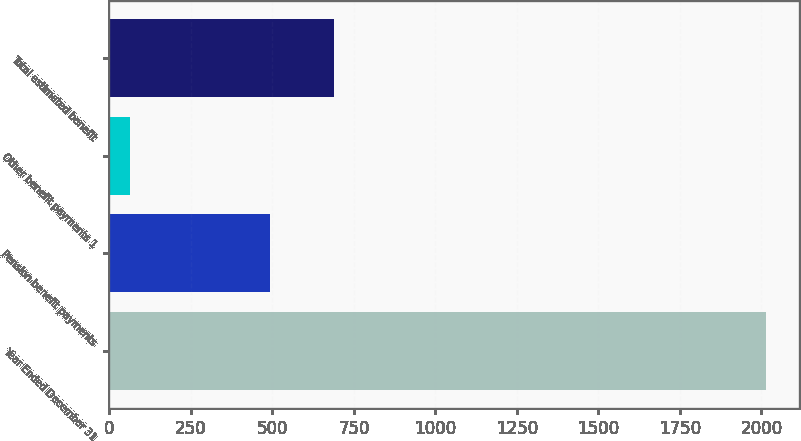Convert chart. <chart><loc_0><loc_0><loc_500><loc_500><bar_chart><fcel>Year Ended December 31<fcel>Pension benefit payments<fcel>Other benefit payments 1<fcel>Total estimated benefit<nl><fcel>2015<fcel>493<fcel>64<fcel>688.1<nl></chart> 